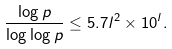Convert formula to latex. <formula><loc_0><loc_0><loc_500><loc_500>\frac { \log p } { \log \log p } \leq 5 . 7 l ^ { 2 } \times 1 0 ^ { l } .</formula> 